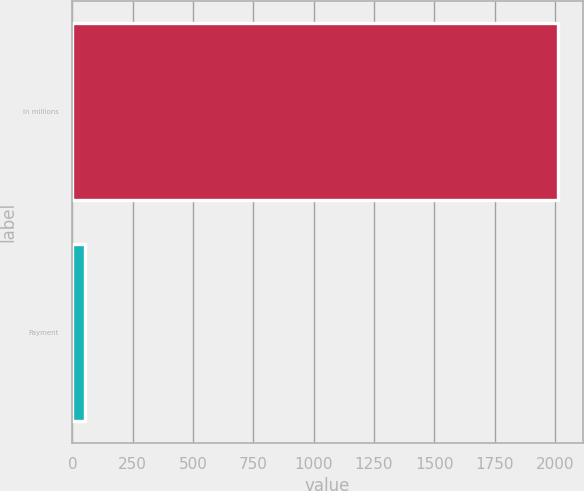Convert chart to OTSL. <chart><loc_0><loc_0><loc_500><loc_500><bar_chart><fcel>In millions<fcel>Payment<nl><fcel>2014<fcel>51<nl></chart> 